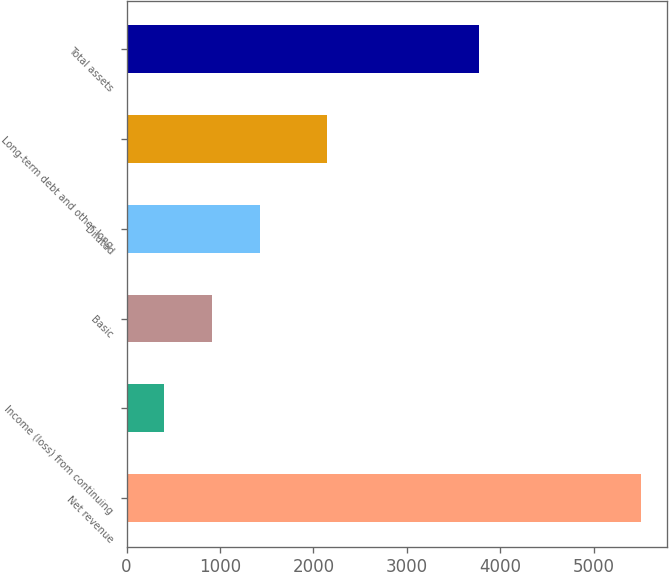Convert chart. <chart><loc_0><loc_0><loc_500><loc_500><bar_chart><fcel>Net revenue<fcel>Income (loss) from continuing<fcel>Basic<fcel>Diluted<fcel>Long-term debt and other long<fcel>Total assets<nl><fcel>5506<fcel>403<fcel>913.3<fcel>1423.6<fcel>2140<fcel>3767<nl></chart> 